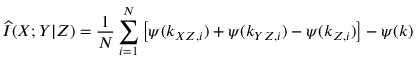<formula> <loc_0><loc_0><loc_500><loc_500>\widehat { I } ( X ; Y | Z ) = \frac { 1 } { N } \sum _ { i = 1 } ^ { N } \left [ \psi ( k _ { X Z , i } ) + \psi ( k _ { Y Z , i } ) - \psi ( k _ { Z , i } ) \right ] - \psi ( k )</formula> 